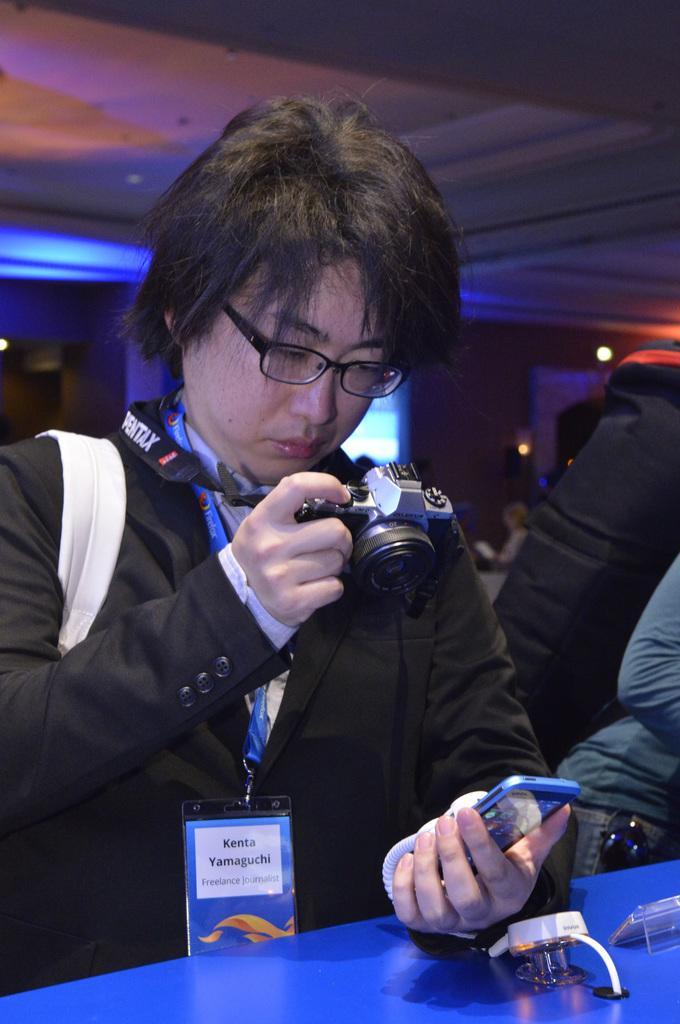Please provide a concise description of this image. In this image we can see a person wearing specs is holding camera and a mobile. There is a blue surface. On that there are few objects. And the person is wearing a tag. In the background there are lights. 